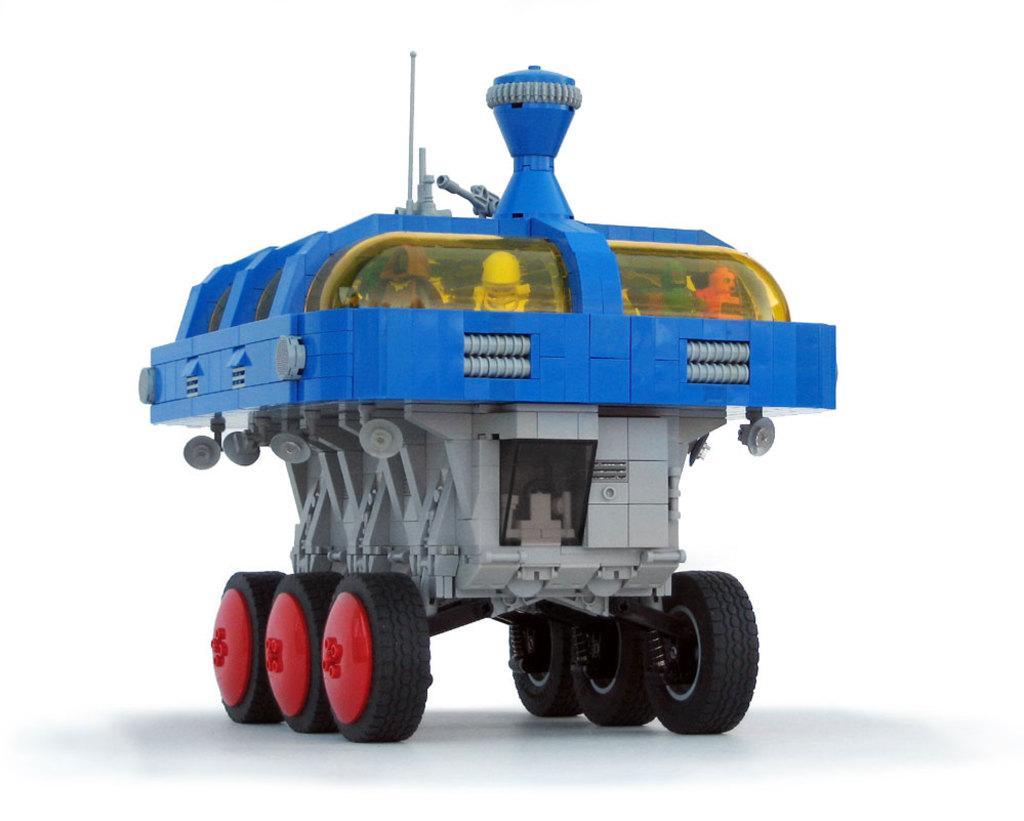In one or two sentences, can you explain what this image depicts? In this image we can see a toy motor vehicle. 